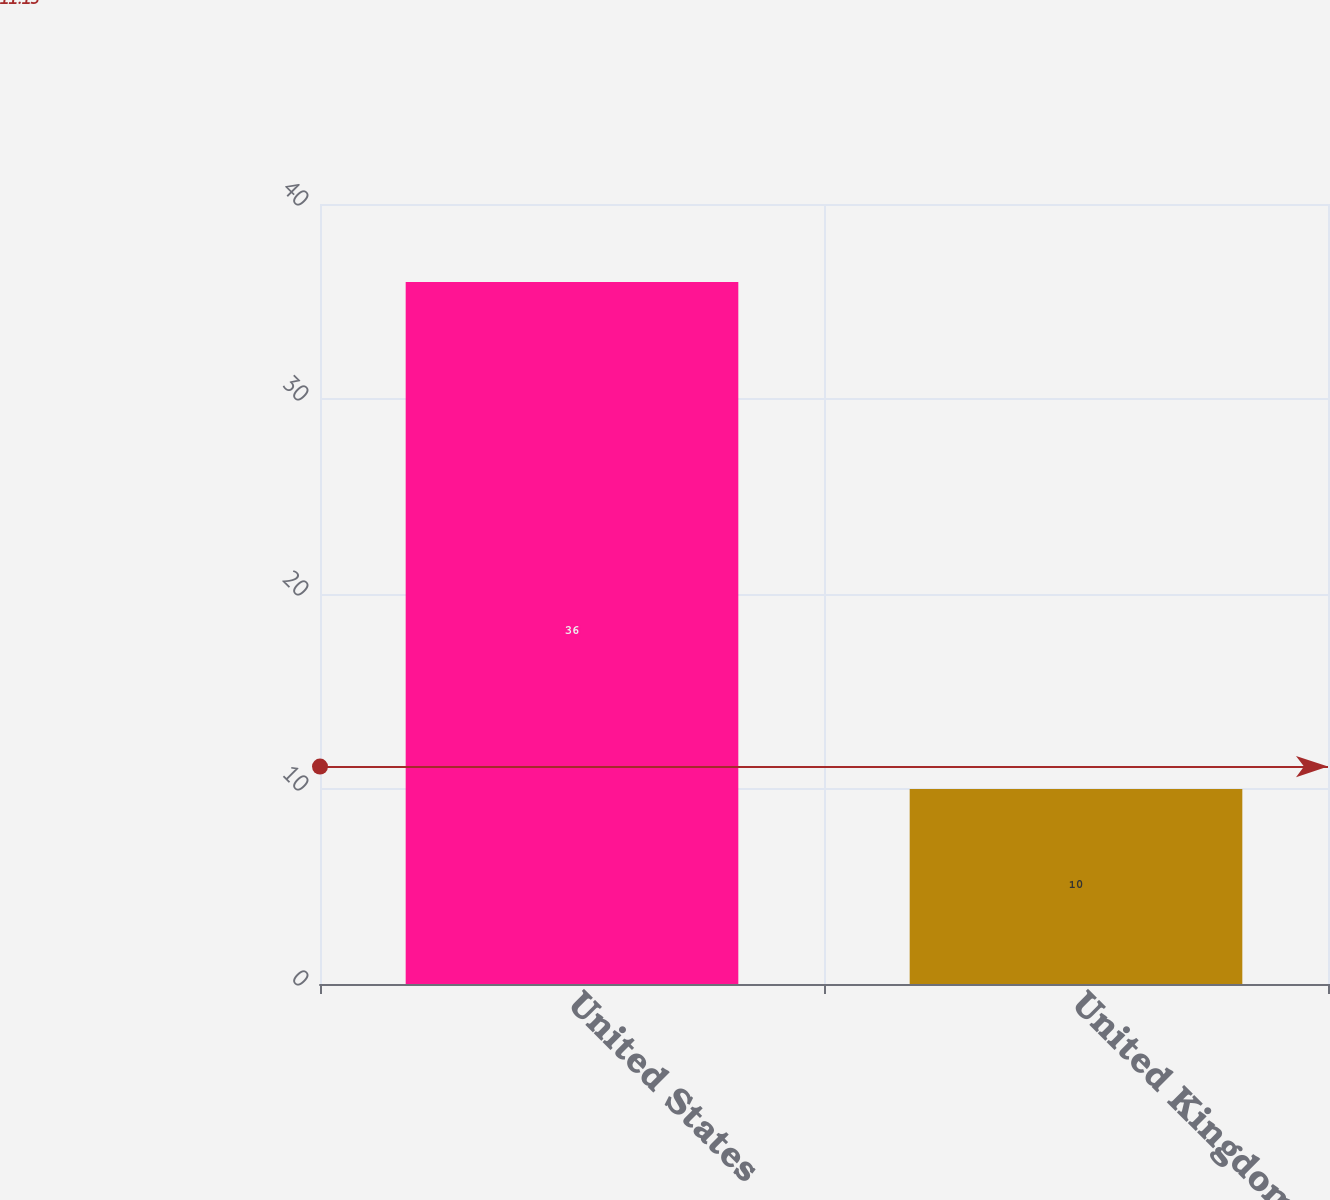Convert chart. <chart><loc_0><loc_0><loc_500><loc_500><bar_chart><fcel>United States<fcel>United Kingdom<nl><fcel>36<fcel>10<nl></chart> 